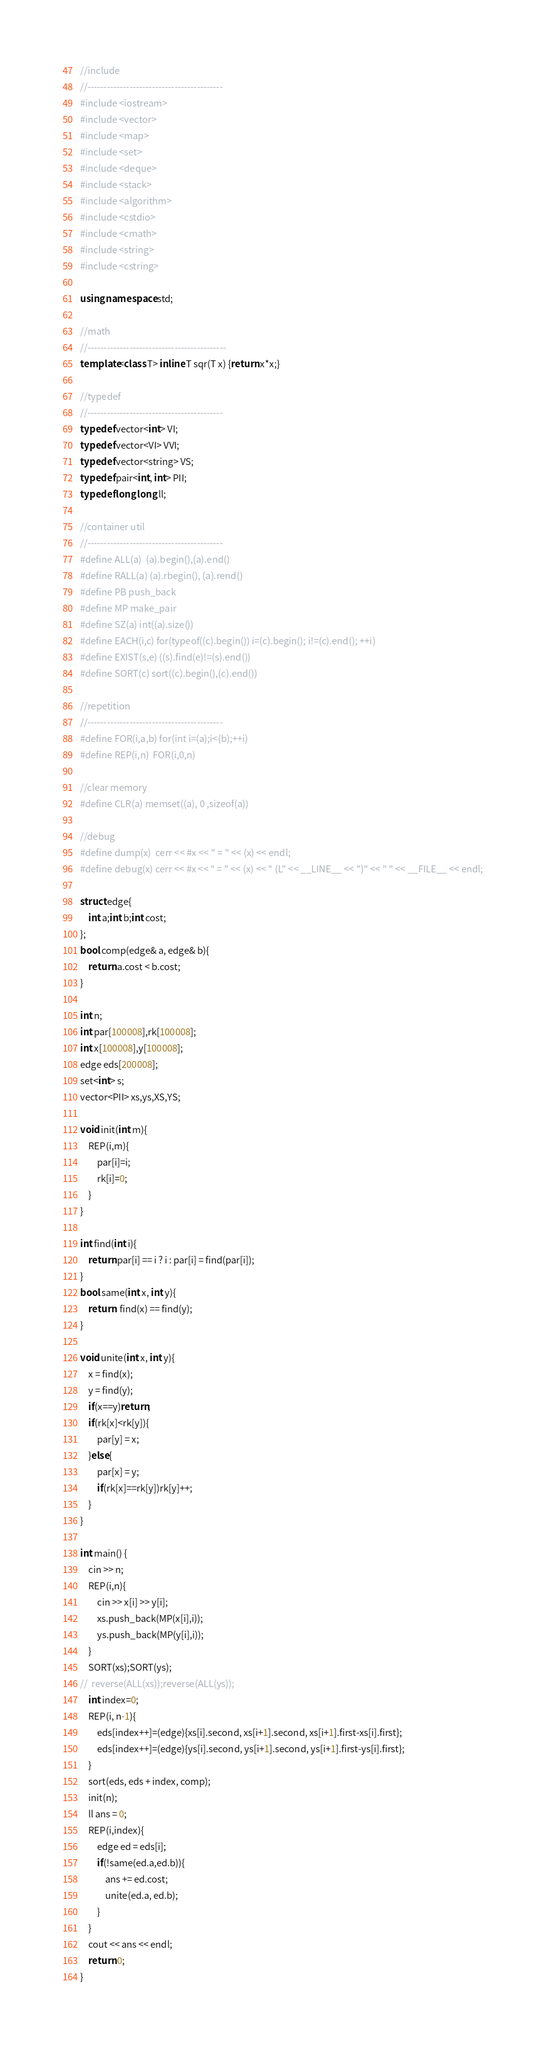Convert code to text. <code><loc_0><loc_0><loc_500><loc_500><_C++_>//include
//------------------------------------------
#include <iostream>
#include <vector>
#include <map>
#include <set>
#include <deque>
#include <stack>
#include <algorithm>
#include <cstdio>
#include <cmath>
#include <string>
#include <cstring>

using namespace std;

//math
//-------------------------------------------
template<class T> inline T sqr(T x) {return x*x;}

//typedef
//------------------------------------------
typedef vector<int> VI;
typedef vector<VI> VVI;
typedef vector<string> VS;
typedef pair<int, int> PII;
typedef long long ll;

//container util
//------------------------------------------
#define ALL(a)  (a).begin(),(a).end()
#define RALL(a) (a).rbegin(), (a).rend()
#define PB push_back
#define MP make_pair
#define SZ(a) int((a).size())
#define EACH(i,c) for(typeof((c).begin()) i=(c).begin(); i!=(c).end(); ++i)
#define EXIST(s,e) ((s).find(e)!=(s).end())
#define SORT(c) sort((c).begin(),(c).end())

//repetition
//------------------------------------------
#define FOR(i,a,b) for(int i=(a);i<(b);++i)
#define REP(i,n)  FOR(i,0,n)

//clear memory
#define CLR(a) memset((a), 0 ,sizeof(a))

//debug
#define dump(x)  cerr << #x << " = " << (x) << endl;
#define debug(x) cerr << #x << " = " << (x) << " (L" << __LINE__ << ")" << " " << __FILE__ << endl;

struct edge{
	int a;int b;int cost;
};
bool comp(edge& a, edge& b){
	return a.cost < b.cost;
}

int n;
int par[100008],rk[100008];
int x[100008],y[100008];
edge eds[200008];
set<int> s;
vector<PII> xs,ys,XS,YS;

void init(int m){
	REP(i,m){
		par[i]=i;
		rk[i]=0;
	}
}

int find(int i){
	return par[i] == i ? i : par[i] = find(par[i]);
}
bool same(int x, int y){
	return  find(x) == find(y);
}

void unite(int x, int y){
	x = find(x);
	y = find(y);
	if(x==y)return;
	if(rk[x]<rk[y]){
		par[y] = x;
	}else{
		par[x] = y;
		if(rk[x]==rk[y])rk[y]++;
	}
}

int main() {
	cin >> n;
	REP(i,n){
		cin >> x[i] >> y[i];
		xs.push_back(MP(x[i],i));
		ys.push_back(MP(y[i],i));
	}
	SORT(xs);SORT(ys);
//	reverse(ALL(xs));reverse(ALL(ys));
	int index=0;
	REP(i, n-1){
		eds[index++]=(edge){xs[i].second, xs[i+1].second, xs[i+1].first-xs[i].first};
		eds[index++]=(edge){ys[i].second, ys[i+1].second, ys[i+1].first-ys[i].first};
	}
	sort(eds, eds + index, comp);
	init(n);
	ll ans = 0;
	REP(i,index){
		edge ed = eds[i];
		if(!same(ed.a,ed.b)){
			ans += ed.cost;
			unite(ed.a, ed.b);
		}
	}
	cout << ans << endl;
	return 0;
}

</code> 